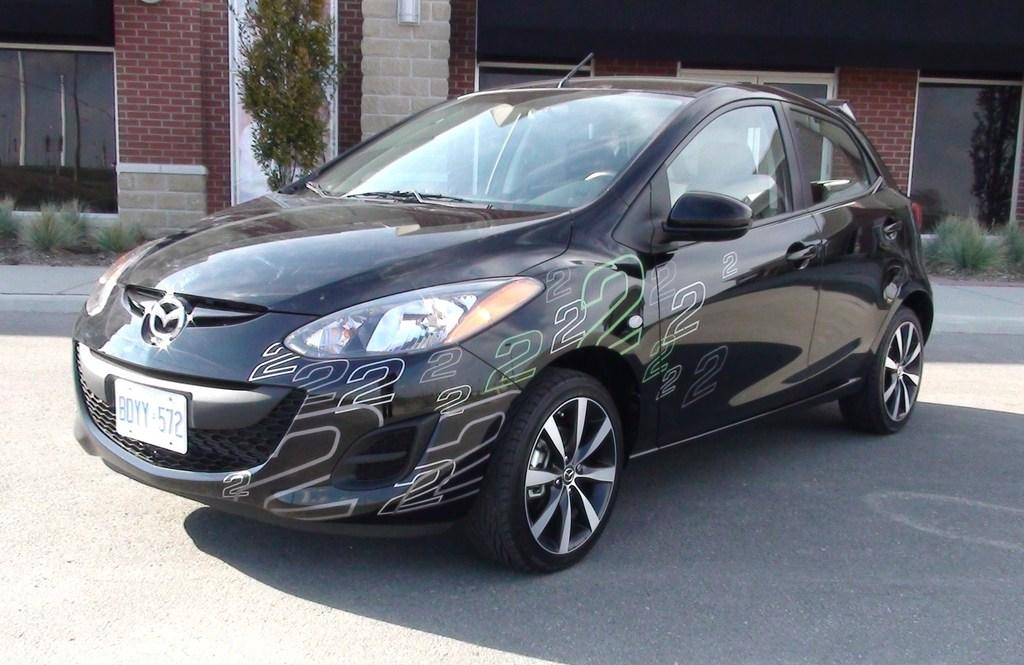What type of vehicle is in the image? There is a black car in the image. What type of structures can be seen in the image? There are buildings in the image. What type of natural element is in the image? There is a tree in the image. What type of vegetation is in the image? There are plants in the image. What type of material is used for the windows in the image? There are glass windows in the image. What type of coil is wrapped around the tree in the image? There is no coil wrapped around the tree in the image. What shape is the yam that is being held by the person in the image? There is no person or yam present in the image. 